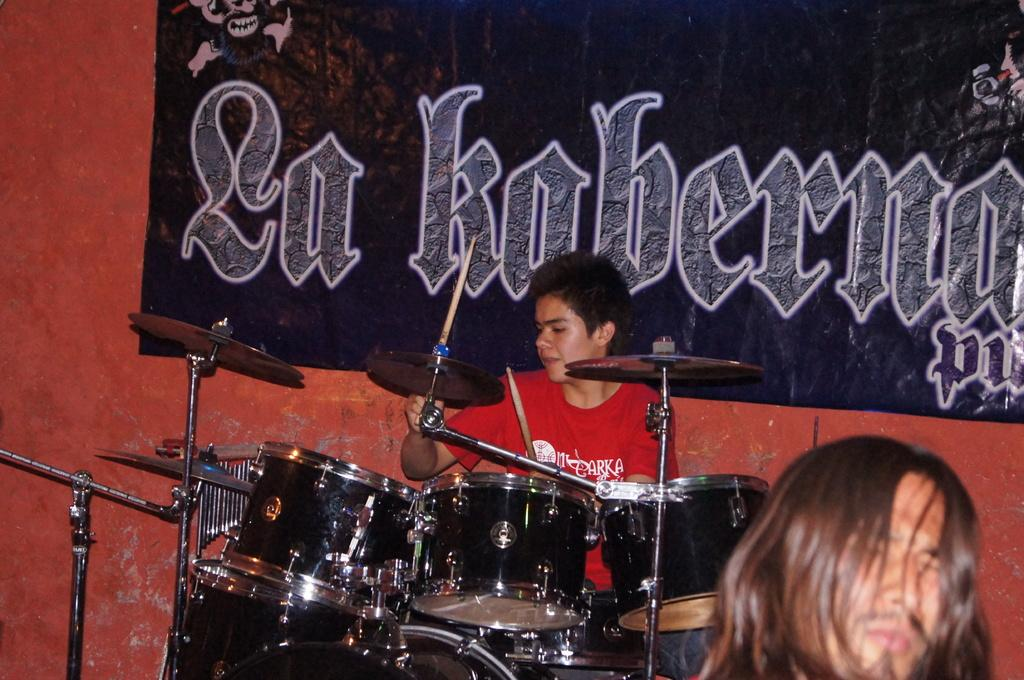What is the person in the image doing? The person is sitting in the image and holding stocks. What other objects can be seen in the image? There are music drums in the image. What is visible in the background of the image? There is a poster in the background of the image. How many dolls are sitting on the land in the image? There are no dolls or land present in the image. 